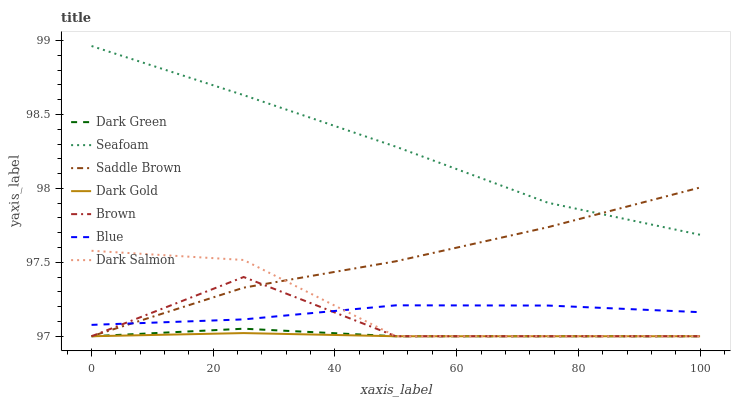Does Dark Gold have the minimum area under the curve?
Answer yes or no. Yes. Does Seafoam have the maximum area under the curve?
Answer yes or no. Yes. Does Brown have the minimum area under the curve?
Answer yes or no. No. Does Brown have the maximum area under the curve?
Answer yes or no. No. Is Dark Gold the smoothest?
Answer yes or no. Yes. Is Brown the roughest?
Answer yes or no. Yes. Is Brown the smoothest?
Answer yes or no. No. Is Dark Gold the roughest?
Answer yes or no. No. Does Brown have the lowest value?
Answer yes or no. Yes. Does Seafoam have the lowest value?
Answer yes or no. No. Does Seafoam have the highest value?
Answer yes or no. Yes. Does Brown have the highest value?
Answer yes or no. No. Is Dark Gold less than Seafoam?
Answer yes or no. Yes. Is Seafoam greater than Dark Salmon?
Answer yes or no. Yes. Does Blue intersect Saddle Brown?
Answer yes or no. Yes. Is Blue less than Saddle Brown?
Answer yes or no. No. Is Blue greater than Saddle Brown?
Answer yes or no. No. Does Dark Gold intersect Seafoam?
Answer yes or no. No. 